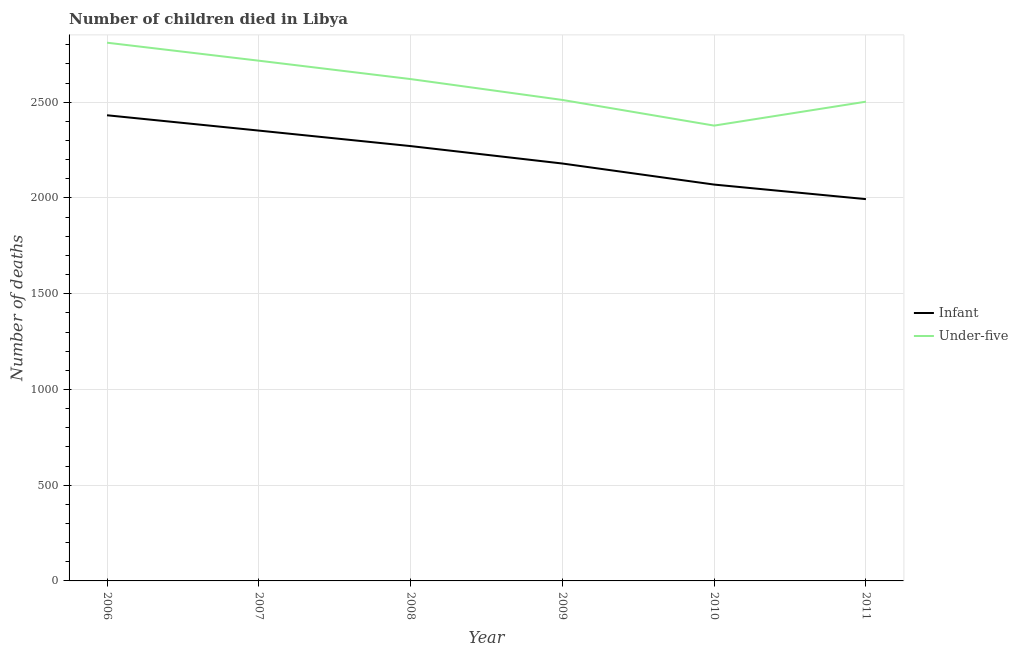Does the line corresponding to number of infant deaths intersect with the line corresponding to number of under-five deaths?
Provide a succinct answer. No. What is the number of under-five deaths in 2010?
Provide a succinct answer. 2378. Across all years, what is the maximum number of infant deaths?
Give a very brief answer. 2432. What is the total number of under-five deaths in the graph?
Your response must be concise. 1.55e+04. What is the difference between the number of under-five deaths in 2007 and that in 2011?
Give a very brief answer. 214. What is the difference between the number of under-five deaths in 2008 and the number of infant deaths in 2009?
Offer a terse response. 441. What is the average number of infant deaths per year?
Your answer should be compact. 2216.5. In the year 2006, what is the difference between the number of infant deaths and number of under-five deaths?
Your answer should be very brief. -379. What is the ratio of the number of infant deaths in 2007 to that in 2008?
Keep it short and to the point. 1.04. What is the difference between the highest and the lowest number of under-five deaths?
Provide a succinct answer. 433. Is the sum of the number of under-five deaths in 2010 and 2011 greater than the maximum number of infant deaths across all years?
Offer a terse response. Yes. Is the number of under-five deaths strictly less than the number of infant deaths over the years?
Ensure brevity in your answer.  No. Does the graph contain any zero values?
Make the answer very short. No. Does the graph contain grids?
Keep it short and to the point. Yes. Where does the legend appear in the graph?
Give a very brief answer. Center right. What is the title of the graph?
Provide a short and direct response. Number of children died in Libya. Does "Methane emissions" appear as one of the legend labels in the graph?
Offer a terse response. No. What is the label or title of the Y-axis?
Offer a terse response. Number of deaths. What is the Number of deaths of Infant in 2006?
Offer a very short reply. 2432. What is the Number of deaths in Under-five in 2006?
Offer a very short reply. 2811. What is the Number of deaths of Infant in 2007?
Make the answer very short. 2352. What is the Number of deaths of Under-five in 2007?
Provide a short and direct response. 2717. What is the Number of deaths in Infant in 2008?
Provide a short and direct response. 2271. What is the Number of deaths of Under-five in 2008?
Give a very brief answer. 2621. What is the Number of deaths of Infant in 2009?
Your answer should be very brief. 2180. What is the Number of deaths of Under-five in 2009?
Give a very brief answer. 2512. What is the Number of deaths of Infant in 2010?
Give a very brief answer. 2070. What is the Number of deaths of Under-five in 2010?
Provide a succinct answer. 2378. What is the Number of deaths in Infant in 2011?
Provide a short and direct response. 1994. What is the Number of deaths of Under-five in 2011?
Offer a terse response. 2503. Across all years, what is the maximum Number of deaths of Infant?
Offer a very short reply. 2432. Across all years, what is the maximum Number of deaths in Under-five?
Your answer should be very brief. 2811. Across all years, what is the minimum Number of deaths of Infant?
Your answer should be compact. 1994. Across all years, what is the minimum Number of deaths in Under-five?
Ensure brevity in your answer.  2378. What is the total Number of deaths in Infant in the graph?
Provide a short and direct response. 1.33e+04. What is the total Number of deaths in Under-five in the graph?
Keep it short and to the point. 1.55e+04. What is the difference between the Number of deaths in Under-five in 2006 and that in 2007?
Your answer should be very brief. 94. What is the difference between the Number of deaths of Infant in 2006 and that in 2008?
Your answer should be compact. 161. What is the difference between the Number of deaths in Under-five in 2006 and that in 2008?
Your answer should be very brief. 190. What is the difference between the Number of deaths in Infant in 2006 and that in 2009?
Ensure brevity in your answer.  252. What is the difference between the Number of deaths of Under-five in 2006 and that in 2009?
Your answer should be compact. 299. What is the difference between the Number of deaths of Infant in 2006 and that in 2010?
Ensure brevity in your answer.  362. What is the difference between the Number of deaths of Under-five in 2006 and that in 2010?
Make the answer very short. 433. What is the difference between the Number of deaths in Infant in 2006 and that in 2011?
Provide a succinct answer. 438. What is the difference between the Number of deaths of Under-five in 2006 and that in 2011?
Make the answer very short. 308. What is the difference between the Number of deaths of Under-five in 2007 and that in 2008?
Provide a short and direct response. 96. What is the difference between the Number of deaths in Infant in 2007 and that in 2009?
Your answer should be compact. 172. What is the difference between the Number of deaths in Under-five in 2007 and that in 2009?
Offer a very short reply. 205. What is the difference between the Number of deaths in Infant in 2007 and that in 2010?
Offer a terse response. 282. What is the difference between the Number of deaths in Under-five in 2007 and that in 2010?
Offer a very short reply. 339. What is the difference between the Number of deaths of Infant in 2007 and that in 2011?
Your response must be concise. 358. What is the difference between the Number of deaths of Under-five in 2007 and that in 2011?
Give a very brief answer. 214. What is the difference between the Number of deaths of Infant in 2008 and that in 2009?
Offer a terse response. 91. What is the difference between the Number of deaths of Under-five in 2008 and that in 2009?
Give a very brief answer. 109. What is the difference between the Number of deaths of Infant in 2008 and that in 2010?
Make the answer very short. 201. What is the difference between the Number of deaths in Under-five in 2008 and that in 2010?
Offer a terse response. 243. What is the difference between the Number of deaths in Infant in 2008 and that in 2011?
Provide a short and direct response. 277. What is the difference between the Number of deaths of Under-five in 2008 and that in 2011?
Keep it short and to the point. 118. What is the difference between the Number of deaths of Infant in 2009 and that in 2010?
Your response must be concise. 110. What is the difference between the Number of deaths of Under-five in 2009 and that in 2010?
Provide a short and direct response. 134. What is the difference between the Number of deaths of Infant in 2009 and that in 2011?
Your response must be concise. 186. What is the difference between the Number of deaths in Under-five in 2009 and that in 2011?
Provide a short and direct response. 9. What is the difference between the Number of deaths in Under-five in 2010 and that in 2011?
Make the answer very short. -125. What is the difference between the Number of deaths of Infant in 2006 and the Number of deaths of Under-five in 2007?
Keep it short and to the point. -285. What is the difference between the Number of deaths of Infant in 2006 and the Number of deaths of Under-five in 2008?
Your response must be concise. -189. What is the difference between the Number of deaths of Infant in 2006 and the Number of deaths of Under-five in 2009?
Your answer should be very brief. -80. What is the difference between the Number of deaths of Infant in 2006 and the Number of deaths of Under-five in 2011?
Give a very brief answer. -71. What is the difference between the Number of deaths in Infant in 2007 and the Number of deaths in Under-five in 2008?
Your answer should be compact. -269. What is the difference between the Number of deaths in Infant in 2007 and the Number of deaths in Under-five in 2009?
Make the answer very short. -160. What is the difference between the Number of deaths of Infant in 2007 and the Number of deaths of Under-five in 2011?
Provide a short and direct response. -151. What is the difference between the Number of deaths of Infant in 2008 and the Number of deaths of Under-five in 2009?
Give a very brief answer. -241. What is the difference between the Number of deaths in Infant in 2008 and the Number of deaths in Under-five in 2010?
Give a very brief answer. -107. What is the difference between the Number of deaths in Infant in 2008 and the Number of deaths in Under-five in 2011?
Ensure brevity in your answer.  -232. What is the difference between the Number of deaths of Infant in 2009 and the Number of deaths of Under-five in 2010?
Provide a short and direct response. -198. What is the difference between the Number of deaths in Infant in 2009 and the Number of deaths in Under-five in 2011?
Provide a short and direct response. -323. What is the difference between the Number of deaths in Infant in 2010 and the Number of deaths in Under-five in 2011?
Your response must be concise. -433. What is the average Number of deaths of Infant per year?
Provide a succinct answer. 2216.5. What is the average Number of deaths of Under-five per year?
Offer a terse response. 2590.33. In the year 2006, what is the difference between the Number of deaths in Infant and Number of deaths in Under-five?
Give a very brief answer. -379. In the year 2007, what is the difference between the Number of deaths of Infant and Number of deaths of Under-five?
Provide a short and direct response. -365. In the year 2008, what is the difference between the Number of deaths in Infant and Number of deaths in Under-five?
Your response must be concise. -350. In the year 2009, what is the difference between the Number of deaths in Infant and Number of deaths in Under-five?
Keep it short and to the point. -332. In the year 2010, what is the difference between the Number of deaths in Infant and Number of deaths in Under-five?
Your response must be concise. -308. In the year 2011, what is the difference between the Number of deaths in Infant and Number of deaths in Under-five?
Your answer should be very brief. -509. What is the ratio of the Number of deaths of Infant in 2006 to that in 2007?
Give a very brief answer. 1.03. What is the ratio of the Number of deaths in Under-five in 2006 to that in 2007?
Provide a succinct answer. 1.03. What is the ratio of the Number of deaths in Infant in 2006 to that in 2008?
Keep it short and to the point. 1.07. What is the ratio of the Number of deaths in Under-five in 2006 to that in 2008?
Offer a terse response. 1.07. What is the ratio of the Number of deaths in Infant in 2006 to that in 2009?
Ensure brevity in your answer.  1.12. What is the ratio of the Number of deaths of Under-five in 2006 to that in 2009?
Your answer should be compact. 1.12. What is the ratio of the Number of deaths of Infant in 2006 to that in 2010?
Give a very brief answer. 1.17. What is the ratio of the Number of deaths of Under-five in 2006 to that in 2010?
Ensure brevity in your answer.  1.18. What is the ratio of the Number of deaths of Infant in 2006 to that in 2011?
Offer a terse response. 1.22. What is the ratio of the Number of deaths in Under-five in 2006 to that in 2011?
Offer a terse response. 1.12. What is the ratio of the Number of deaths of Infant in 2007 to that in 2008?
Your answer should be compact. 1.04. What is the ratio of the Number of deaths in Under-five in 2007 to that in 2008?
Offer a very short reply. 1.04. What is the ratio of the Number of deaths in Infant in 2007 to that in 2009?
Make the answer very short. 1.08. What is the ratio of the Number of deaths in Under-five in 2007 to that in 2009?
Your answer should be compact. 1.08. What is the ratio of the Number of deaths in Infant in 2007 to that in 2010?
Provide a short and direct response. 1.14. What is the ratio of the Number of deaths of Under-five in 2007 to that in 2010?
Offer a terse response. 1.14. What is the ratio of the Number of deaths in Infant in 2007 to that in 2011?
Offer a very short reply. 1.18. What is the ratio of the Number of deaths of Under-five in 2007 to that in 2011?
Offer a terse response. 1.09. What is the ratio of the Number of deaths in Infant in 2008 to that in 2009?
Your response must be concise. 1.04. What is the ratio of the Number of deaths of Under-five in 2008 to that in 2009?
Provide a succinct answer. 1.04. What is the ratio of the Number of deaths of Infant in 2008 to that in 2010?
Provide a succinct answer. 1.1. What is the ratio of the Number of deaths in Under-five in 2008 to that in 2010?
Provide a short and direct response. 1.1. What is the ratio of the Number of deaths of Infant in 2008 to that in 2011?
Your answer should be compact. 1.14. What is the ratio of the Number of deaths in Under-five in 2008 to that in 2011?
Offer a terse response. 1.05. What is the ratio of the Number of deaths of Infant in 2009 to that in 2010?
Your response must be concise. 1.05. What is the ratio of the Number of deaths in Under-five in 2009 to that in 2010?
Offer a terse response. 1.06. What is the ratio of the Number of deaths of Infant in 2009 to that in 2011?
Keep it short and to the point. 1.09. What is the ratio of the Number of deaths of Under-five in 2009 to that in 2011?
Your answer should be compact. 1. What is the ratio of the Number of deaths of Infant in 2010 to that in 2011?
Provide a short and direct response. 1.04. What is the ratio of the Number of deaths of Under-five in 2010 to that in 2011?
Provide a succinct answer. 0.95. What is the difference between the highest and the second highest Number of deaths in Infant?
Your answer should be compact. 80. What is the difference between the highest and the second highest Number of deaths of Under-five?
Ensure brevity in your answer.  94. What is the difference between the highest and the lowest Number of deaths of Infant?
Provide a succinct answer. 438. What is the difference between the highest and the lowest Number of deaths in Under-five?
Provide a succinct answer. 433. 